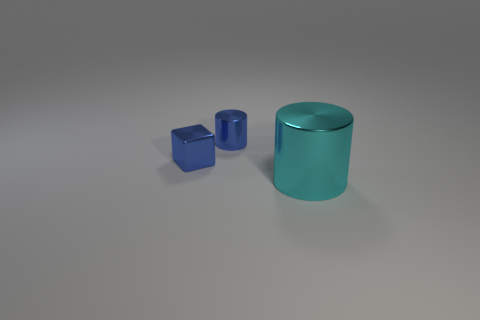There is a tiny object that is in front of the small blue metal cylinder; how many metallic blocks are in front of it?
Provide a succinct answer. 0. How many spheres are either big red matte things or big things?
Make the answer very short. 0. There is a shiny thing that is on the right side of the blue block and behind the big cyan object; what color is it?
Your answer should be compact. Blue. Are there any other things that have the same color as the large cylinder?
Ensure brevity in your answer.  No. There is a thing that is on the right side of the cylinder that is behind the large metal cylinder; what is its color?
Your answer should be very brief. Cyan. Is the size of the shiny cube the same as the cyan metal cylinder?
Offer a very short reply. No. The tiny shiny thing that is right of the object that is to the left of the cylinder that is behind the cyan metallic thing is what shape?
Ensure brevity in your answer.  Cylinder. Is the number of large cyan metallic cylinders greater than the number of yellow blocks?
Your answer should be very brief. Yes. Are any tiny cyan metal spheres visible?
Offer a terse response. No. How many things are either things that are on the right side of the metallic cube or small blue metal cubes that are behind the big shiny thing?
Provide a succinct answer. 3. 